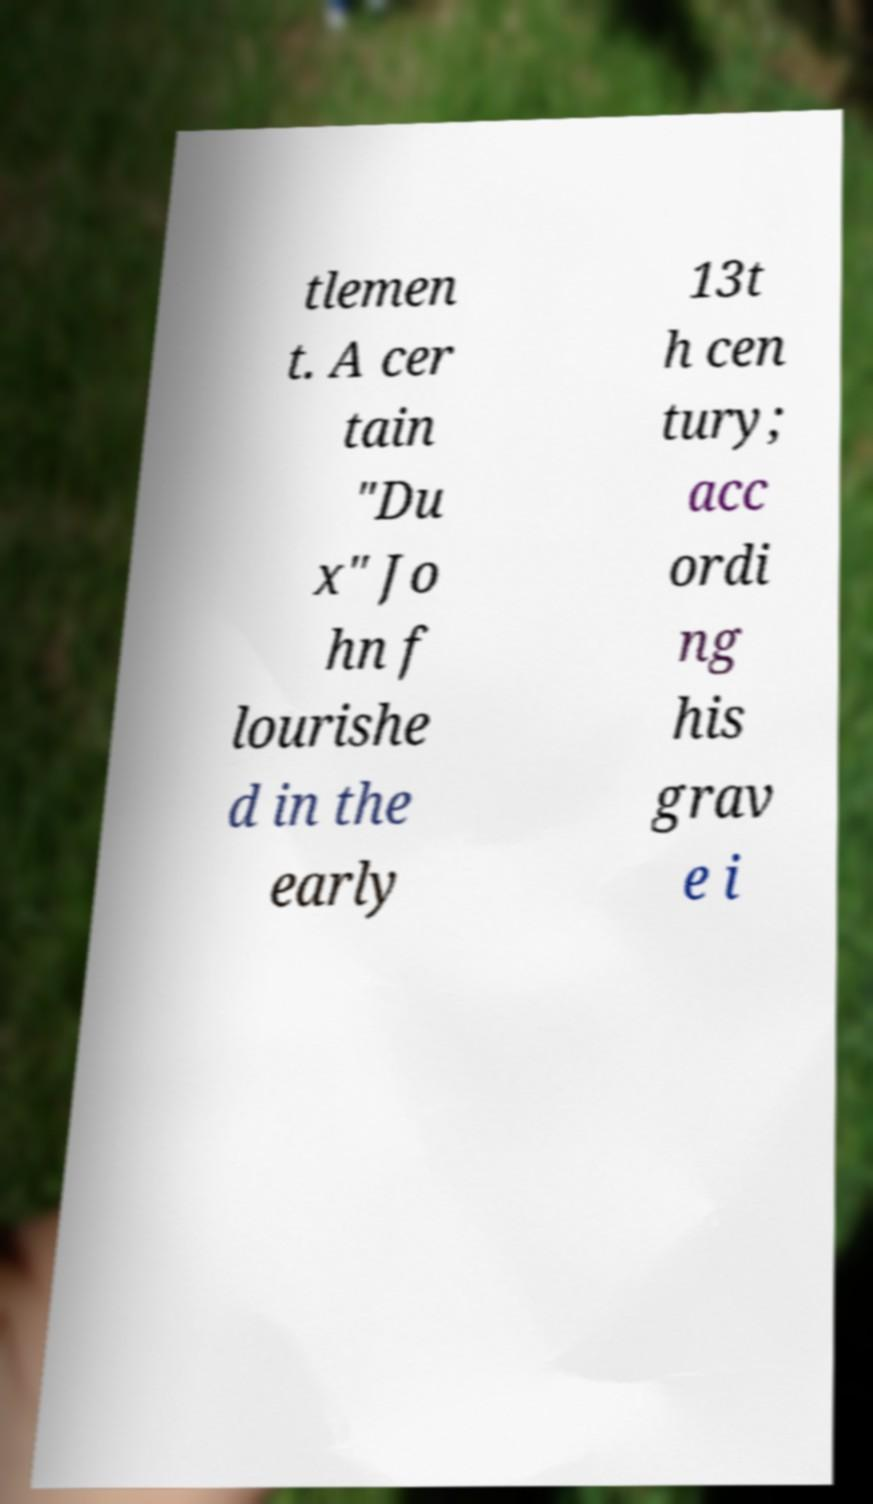Could you extract and type out the text from this image? tlemen t. A cer tain "Du x" Jo hn f lourishe d in the early 13t h cen tury; acc ordi ng his grav e i 